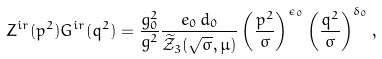<formula> <loc_0><loc_0><loc_500><loc_500>Z ^ { i r } ( p ^ { 2 } ) G ^ { i r } ( q ^ { 2 } ) = \frac { g _ { 0 } ^ { 2 } } { g ^ { 2 } } \frac { e _ { 0 } \, d _ { 0 } } { \widetilde { \mathcal { Z } } _ { 3 } ( \sqrt { \sigma } , \mu ) } \left ( \frac { p ^ { 2 } } { \sigma } \right ) ^ { \epsilon _ { 0 } } \left ( \frac { q ^ { 2 } } { \sigma } \right ) ^ { \delta _ { 0 } } ,</formula> 